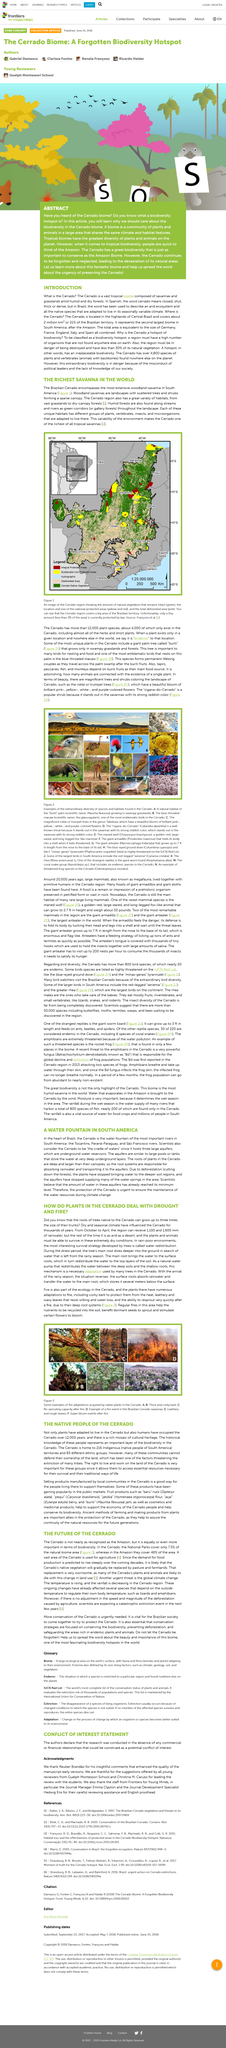Point out several critical features in this image. A woodland savanna is a landscape characterized by the presence of scattered trees and shrubs forming a sparse canopy, with expanses of grassland or herbaceous vegetation. It is imperative that both plants and animals are able to survive extreme conditions in order to thrive in their respective habitats. The fires have a beneficial impact on the environment, as they help plants store nutrients that are recycled into the soil, which is beneficial for the growth and sustainability of the ecosystem. When threatened, the giant armadillo takes the initiative to protect itself by folding into a defensive shell. Cerrado native vegetation is represented by areas highlighted in green on the map. 